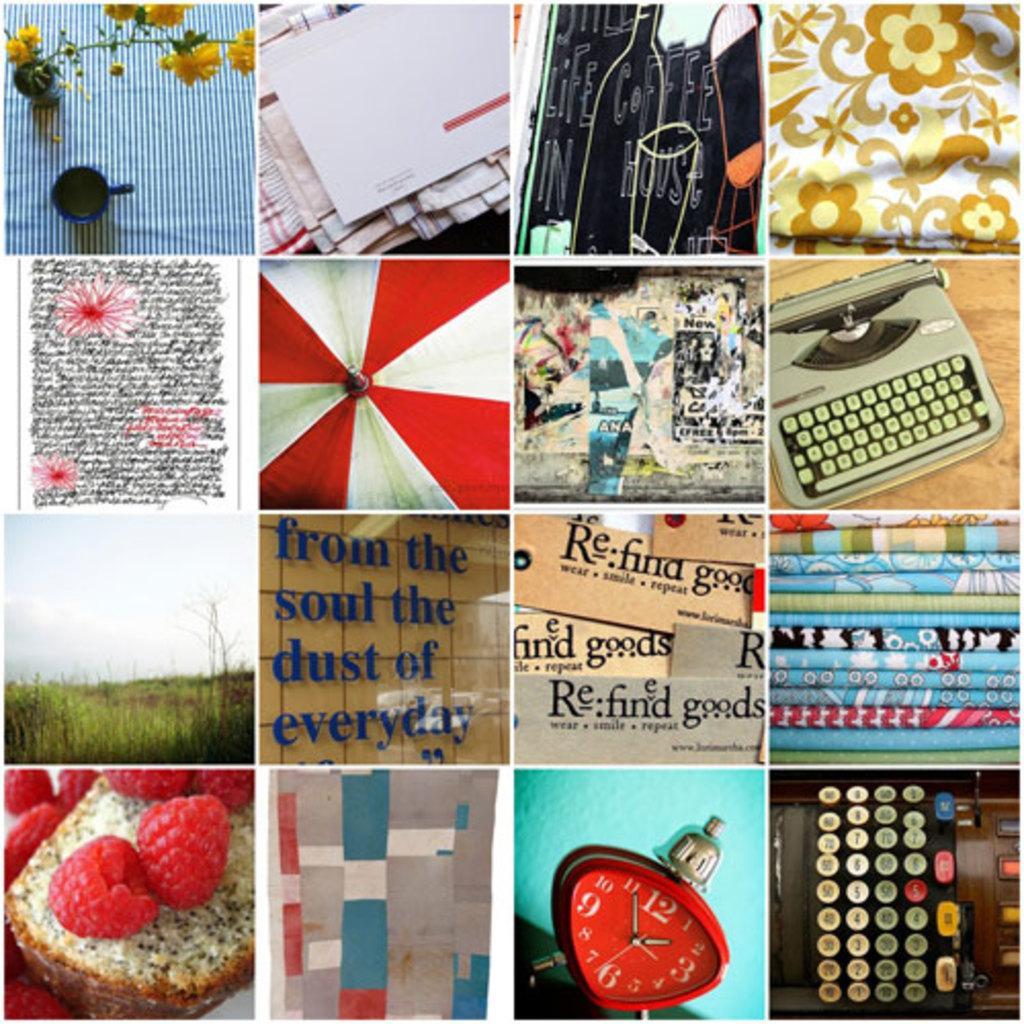Describe this image in one or two sentences. This is a collage. In this picture we can see some food items, text, flower vase, device, cup, clothes, grass and other objects. 